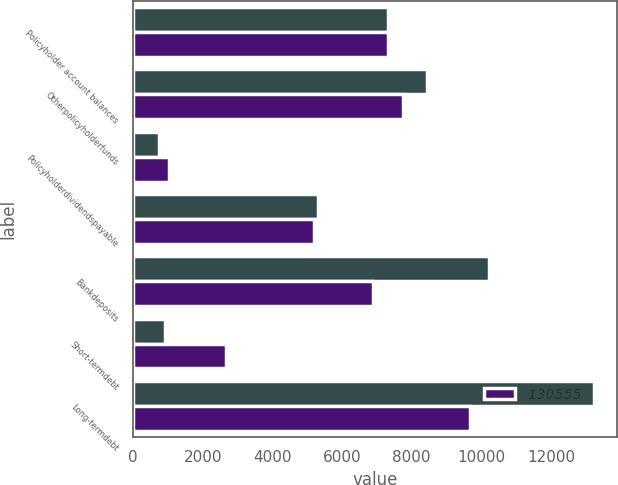Convert chart. <chart><loc_0><loc_0><loc_500><loc_500><stacked_bar_chart><ecel><fcel>Policyholder account balances<fcel>Otherpolicyholderfunds<fcel>Policyholderdividendspayable<fcel>Unnamed: 4<fcel>Bankdeposits<fcel>Short-termdebt<fcel>Long-termdebt<nl><fcel>nan<fcel>7323<fcel>8446<fcel>761<fcel>5297<fcel>10211<fcel>912<fcel>13220<nl><fcel>130555<fcel>7323<fcel>7762<fcel>1023<fcel>5192<fcel>6884<fcel>2659<fcel>9667<nl></chart> 